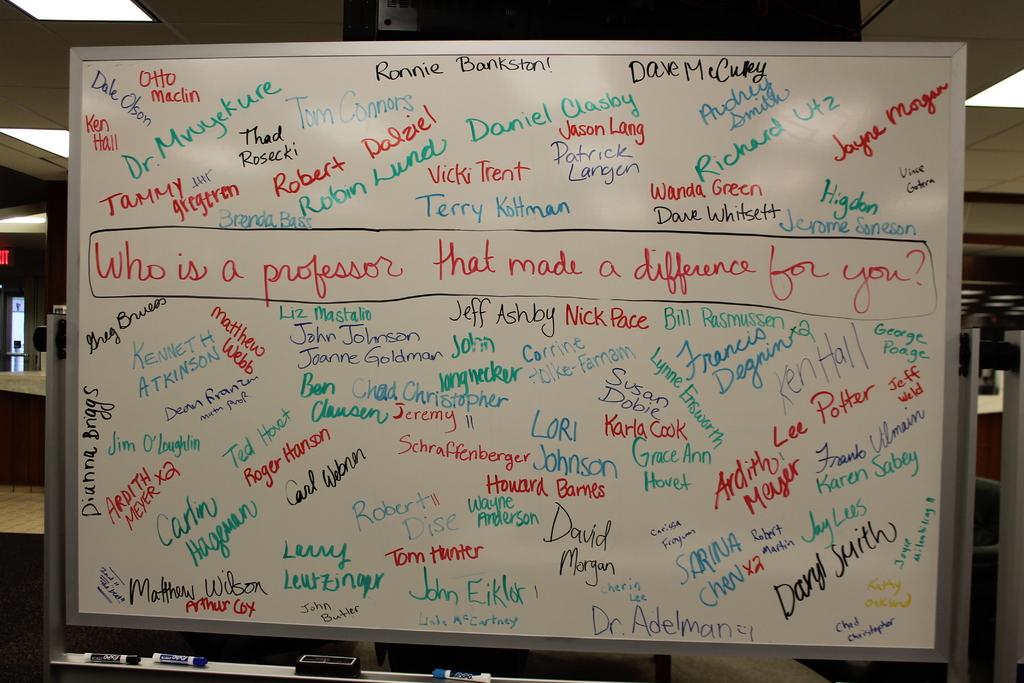The board asks who is a what?
Your response must be concise. Professor. What is one of the name's on the board?
Make the answer very short. Daniel clasby. 